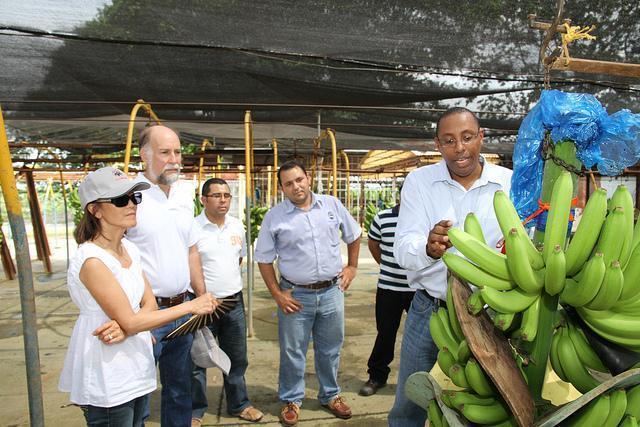How many people have glasses?
Give a very brief answer. 3. How many people are in the photo?
Give a very brief answer. 6. 